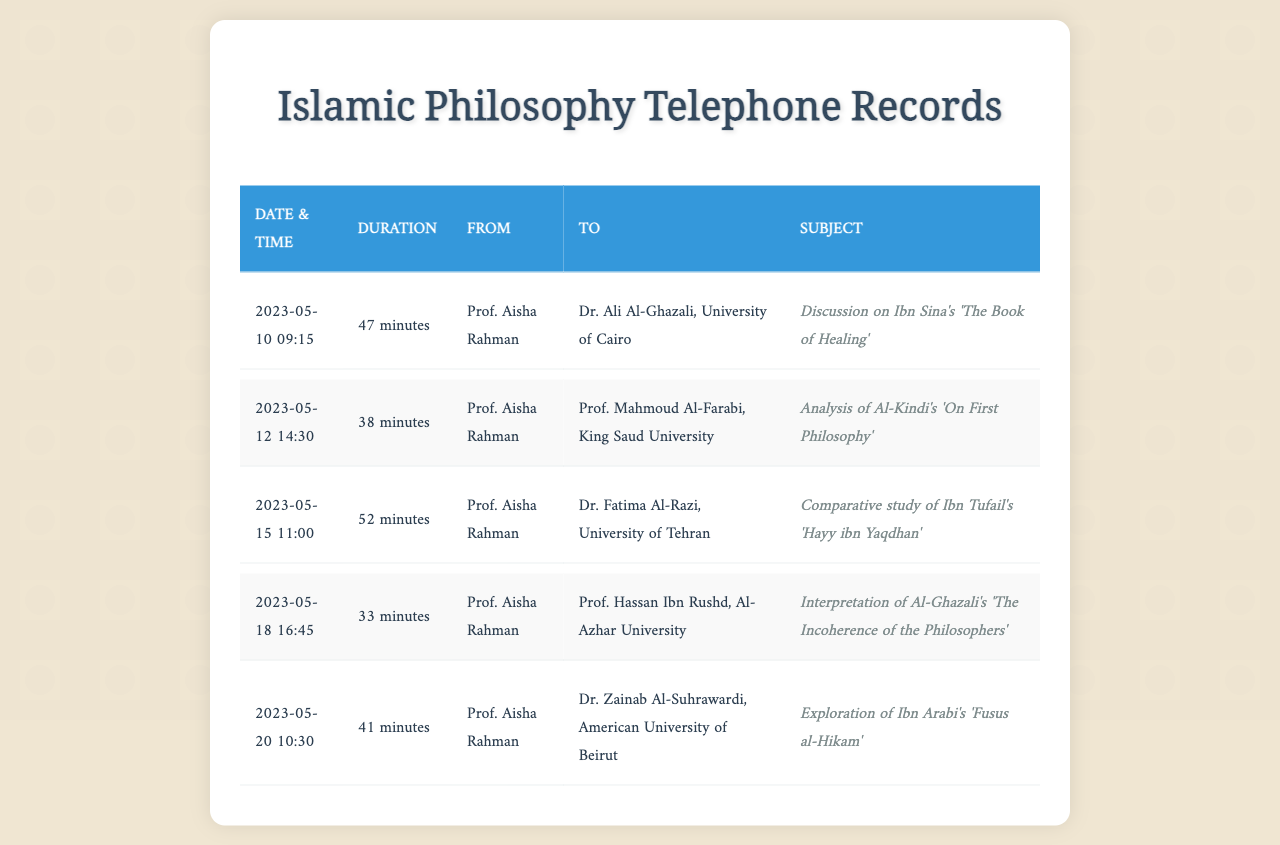What is the first call date recorded? The first entry in the records shows a call on May 10, 2023.
Answer: May 10, 2023 How long was the call to Dr. Ali Al-Ghazali? The duration of the call to Dr. Ali Al-Ghazali is specified as 47 minutes.
Answer: 47 minutes Who did Prof. Aisha Rahman call on May 18, 2023? The records indicate that Prof. Aisha Rahman called Prof. Hassan Ibn Rushd on that date.
Answer: Prof. Hassan Ibn Rushd What was discussed in the call to Dr. Fatima Al-Razi? The subject of the call was a comparative study of Ibn Tufail's 'Hayy ibn Yaqdhan'.
Answer: Comparative study of Ibn Tufail's 'Hayy ibn Yaqdhan' Which university does Dr. Zainab Al-Suhrawardi belong to? Dr. Zainab Al-Suhrawardi is associated with the American University of Beirut.
Answer: American University of Beirut What is the total duration of calls logged in the document? The total duration can be found by adding up the durations of each recorded call.
Answer: 211 minutes 